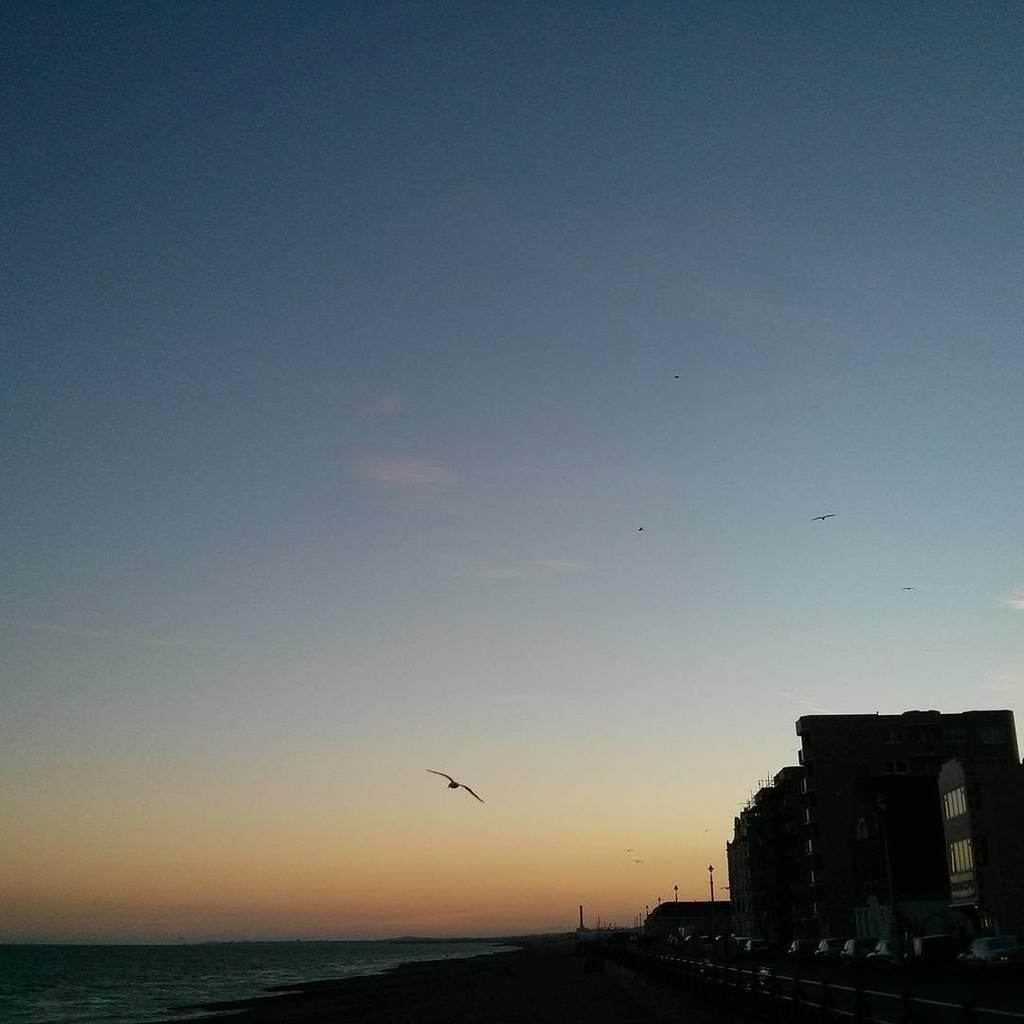In one or two sentences, can you explain what this image depicts? In the picture we can see some buildings and near to it, we can see some poles and water and in the background, we can see a sky with some birds flying in the air. 